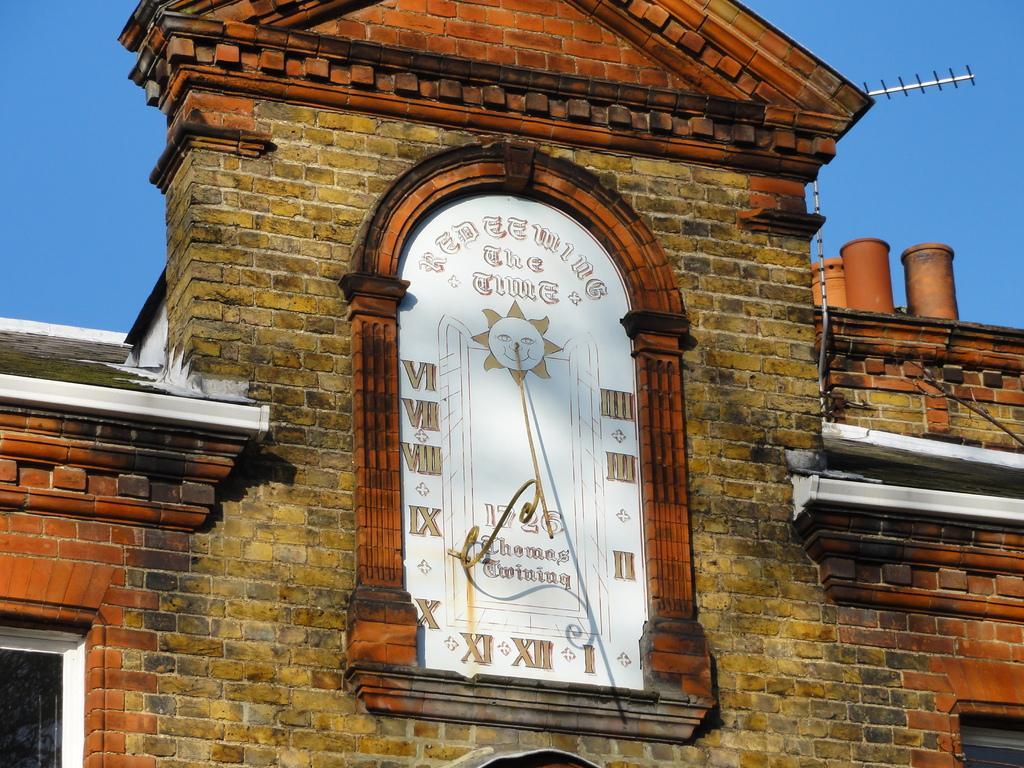<image>
Write a terse but informative summary of the picture. An old clock on a brick building was made by Thomas Twining. 